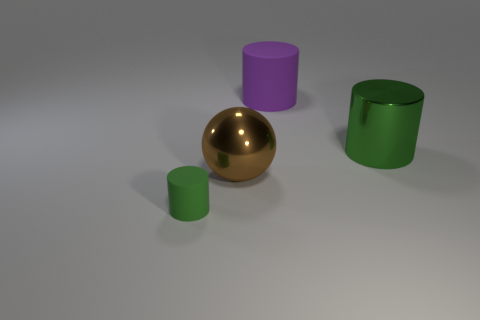There is a rubber cylinder that is the same size as the sphere; what color is it?
Provide a succinct answer. Purple. Does the small cylinder have the same material as the big purple object?
Your answer should be compact. Yes. What material is the cylinder behind the green metallic object that is behind the large brown ball?
Offer a very short reply. Rubber. Is the number of big brown things to the left of the green metal cylinder greater than the number of big gray cylinders?
Keep it short and to the point. Yes. How many other things are the same size as the green rubber cylinder?
Keep it short and to the point. 0. Do the metal cylinder and the tiny cylinder have the same color?
Your response must be concise. Yes. There is a matte thing that is right of the green cylinder to the left of the green thing behind the green rubber cylinder; what is its color?
Give a very brief answer. Purple. How many rubber cylinders are on the right side of the green cylinder on the left side of the big metal thing in front of the big metal cylinder?
Ensure brevity in your answer.  1. Is there any other thing of the same color as the big shiny sphere?
Offer a very short reply. No. There is a green cylinder that is on the right side of the green rubber cylinder; does it have the same size as the big sphere?
Your answer should be compact. Yes. 